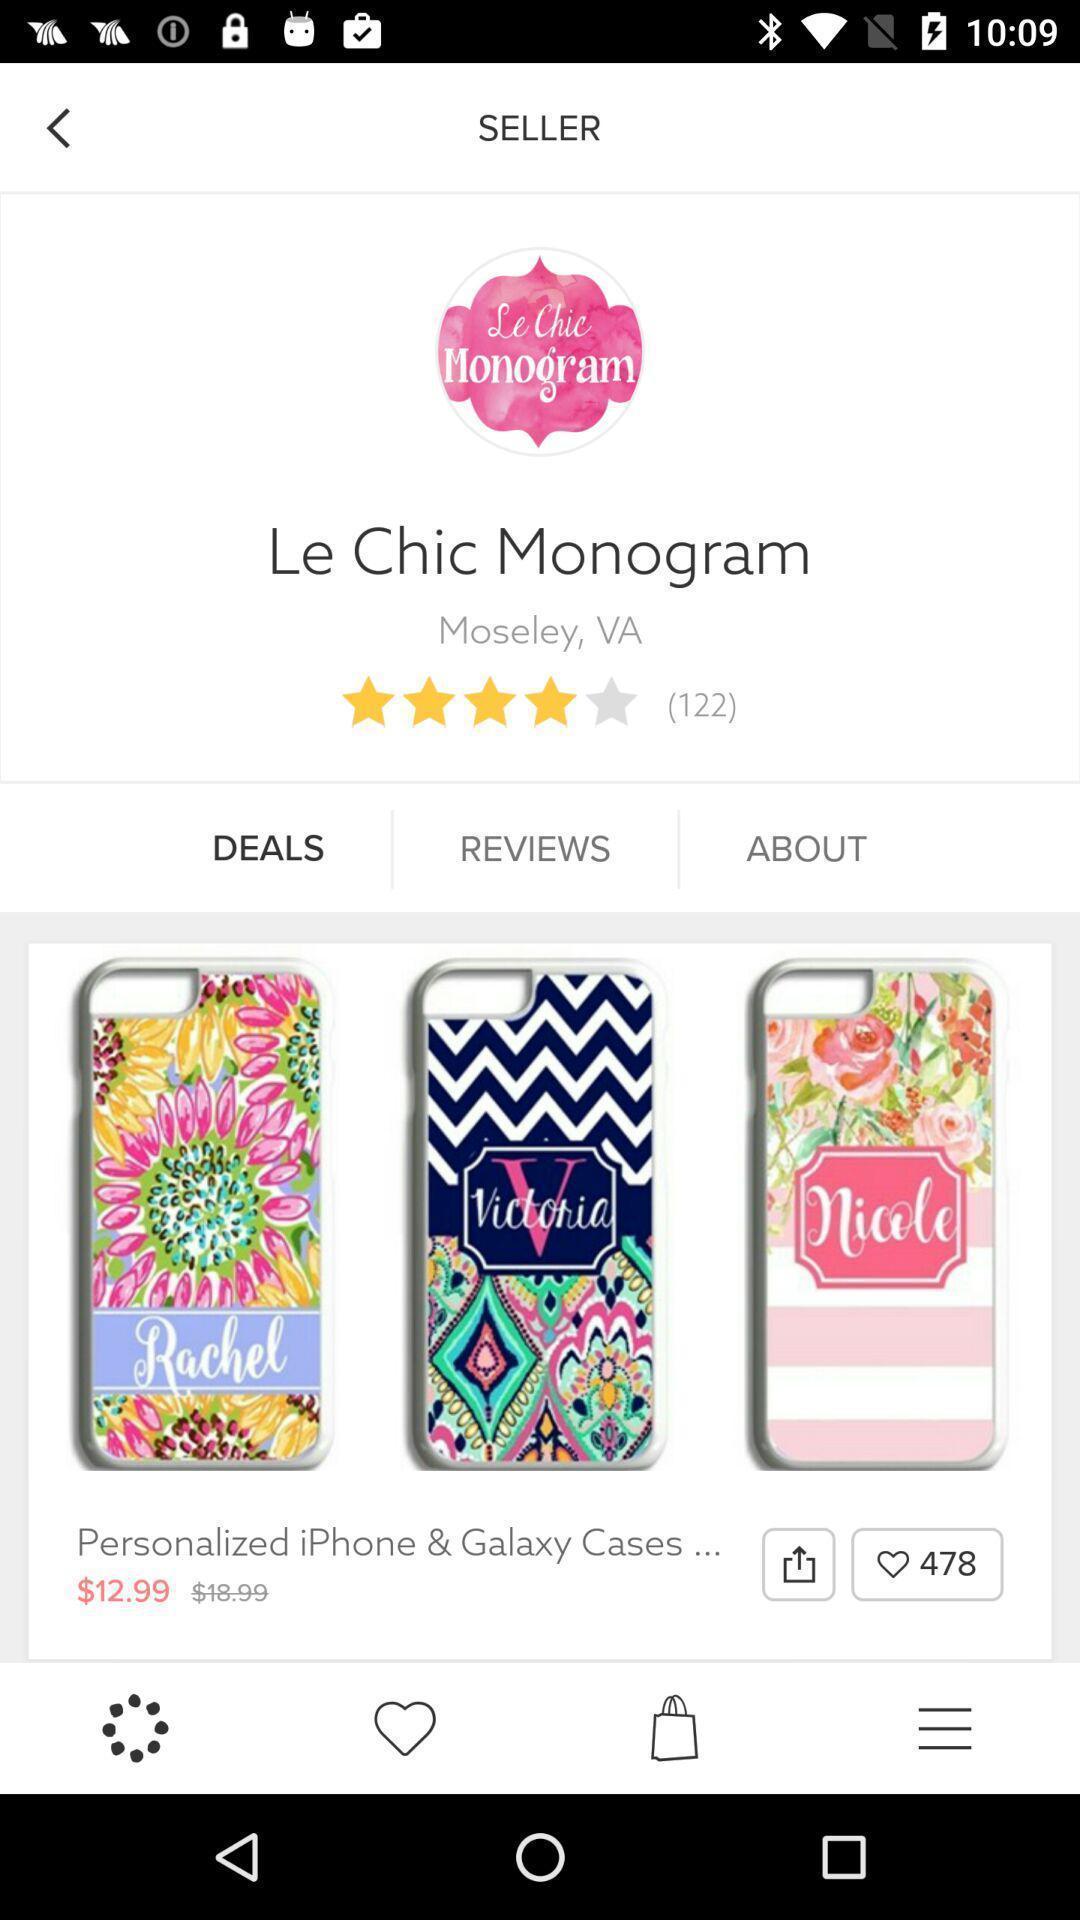Explain what's happening in this screen capture. Screen showing page of an application. 